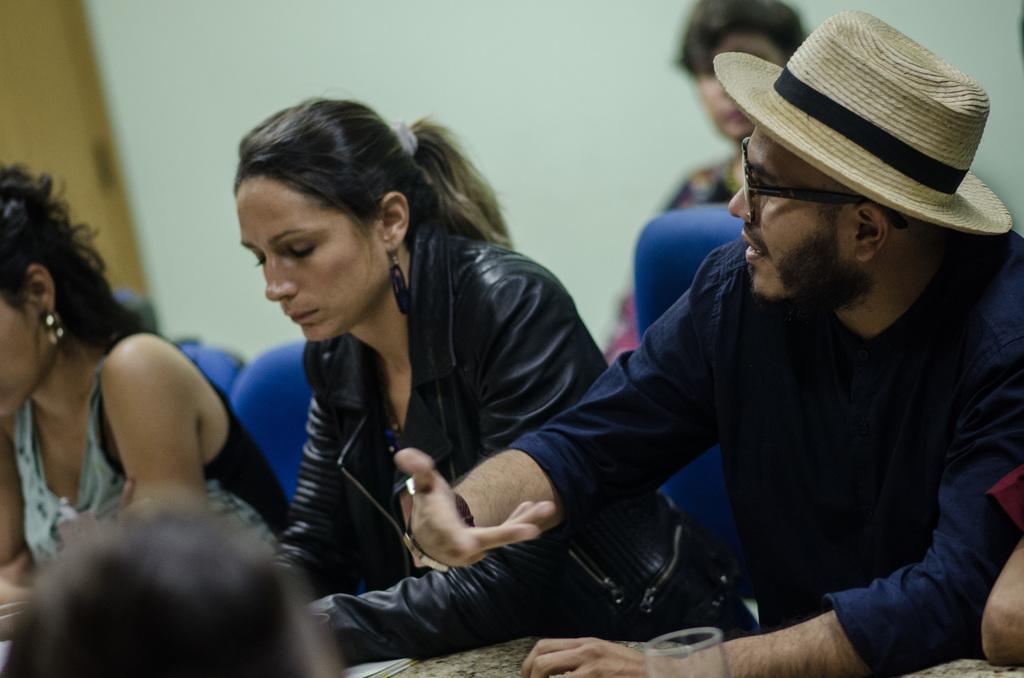Could you give a brief overview of what you see in this image? In this picture there is a woman who is wearing black jacket, beside her we can see a man who is wearing hat, spectacle, t-shirt and watch. He is sitting near to the table. On the table we can see papers and glass. On the left we can see another woman who is sitting on the blue chair. In the bottom left corner we can see the person´s head. In the back there is a woman who is sitting near to the wall. At the top left corner there is a door. 